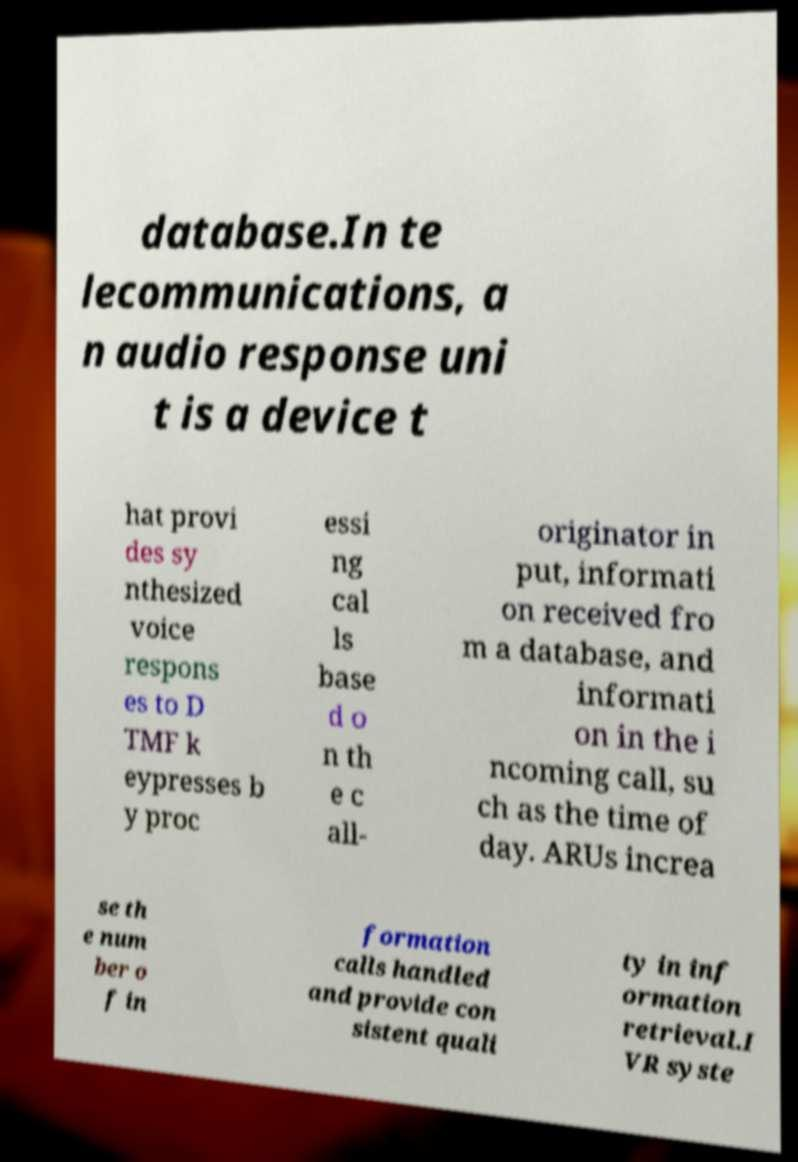For documentation purposes, I need the text within this image transcribed. Could you provide that? database.In te lecommunications, a n audio response uni t is a device t hat provi des sy nthesized voice respons es to D TMF k eypresses b y proc essi ng cal ls base d o n th e c all- originator in put, informati on received fro m a database, and informati on in the i ncoming call, su ch as the time of day. ARUs increa se th e num ber o f in formation calls handled and provide con sistent quali ty in inf ormation retrieval.I VR syste 